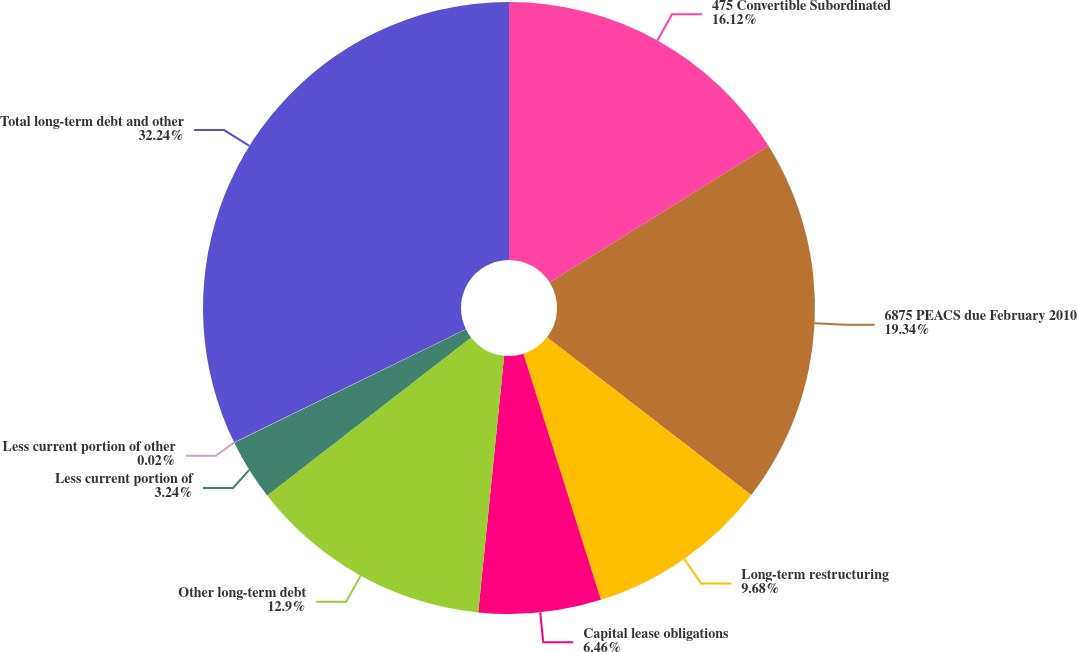Convert chart to OTSL. <chart><loc_0><loc_0><loc_500><loc_500><pie_chart><fcel>475 Convertible Subordinated<fcel>6875 PEACS due February 2010<fcel>Long-term restructuring<fcel>Capital lease obligations<fcel>Other long-term debt<fcel>Less current portion of<fcel>Less current portion of other<fcel>Total long-term debt and other<nl><fcel>16.12%<fcel>19.34%<fcel>9.68%<fcel>6.46%<fcel>12.9%<fcel>3.24%<fcel>0.02%<fcel>32.23%<nl></chart> 